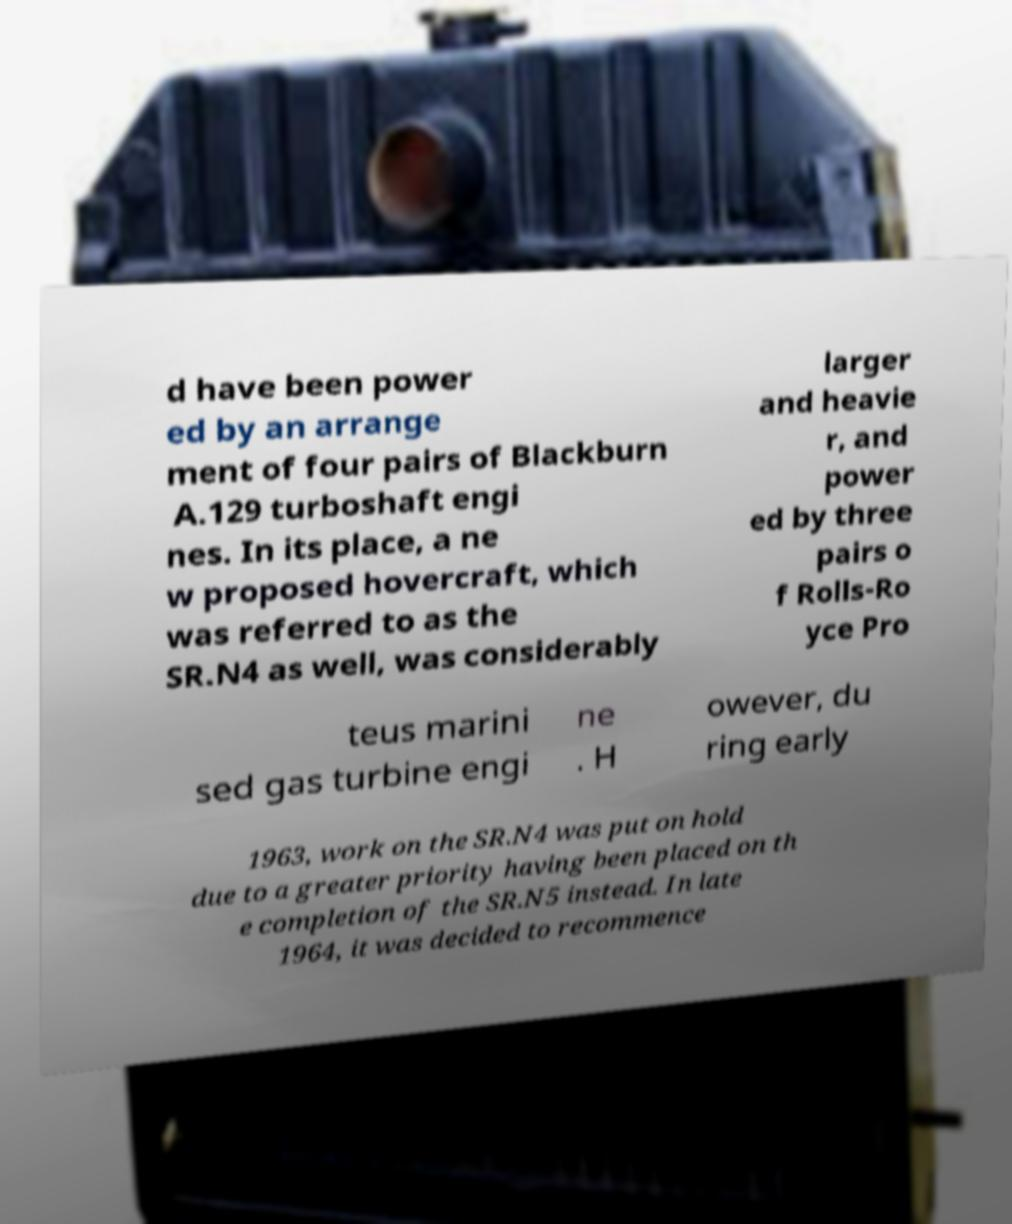What messages or text are displayed in this image? I need them in a readable, typed format. d have been power ed by an arrange ment of four pairs of Blackburn A.129 turboshaft engi nes. In its place, a ne w proposed hovercraft, which was referred to as the SR.N4 as well, was considerably larger and heavie r, and power ed by three pairs o f Rolls-Ro yce Pro teus marini sed gas turbine engi ne . H owever, du ring early 1963, work on the SR.N4 was put on hold due to a greater priority having been placed on th e completion of the SR.N5 instead. In late 1964, it was decided to recommence 